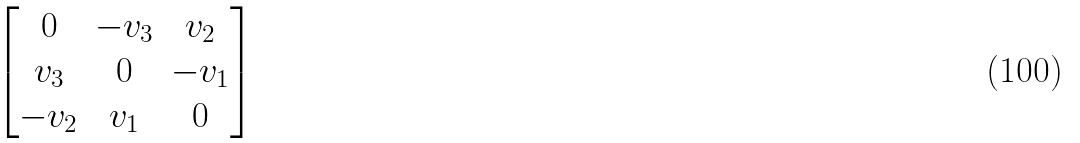<formula> <loc_0><loc_0><loc_500><loc_500>\begin{bmatrix} 0 & - v _ { 3 } & v _ { 2 } \\ v _ { 3 } & 0 & - v _ { 1 } \\ - v _ { 2 } & v _ { 1 } & 0 \end{bmatrix}</formula> 